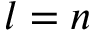Convert formula to latex. <formula><loc_0><loc_0><loc_500><loc_500>l = n</formula> 